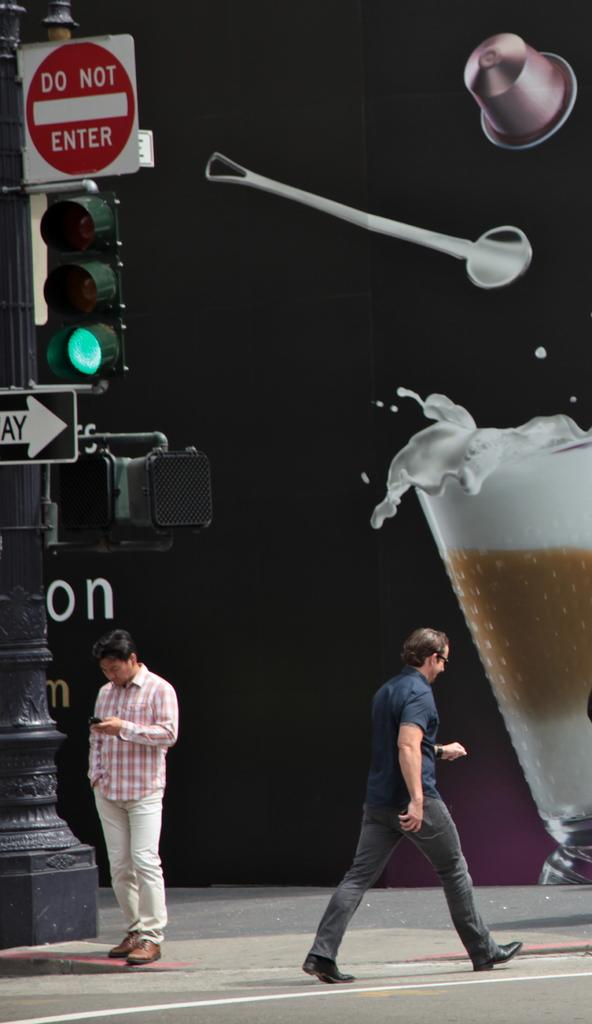What are the two people in the image doing? The two people in the image are walking on a road. What can be seen in the background of the image? There is a street light pole and a big banner in the image. What is depicted on the banner? The banner contains a coffee cup, a spoon, and a hat. What type of activity are the people engaged in on the banner? The banner does not depict any activity involving the people; it only contains a coffee cup, a spoon, and a hat. Can you tell me what the people are wishing for in the image? There is no indication in the image that the people are wishing for anything. 